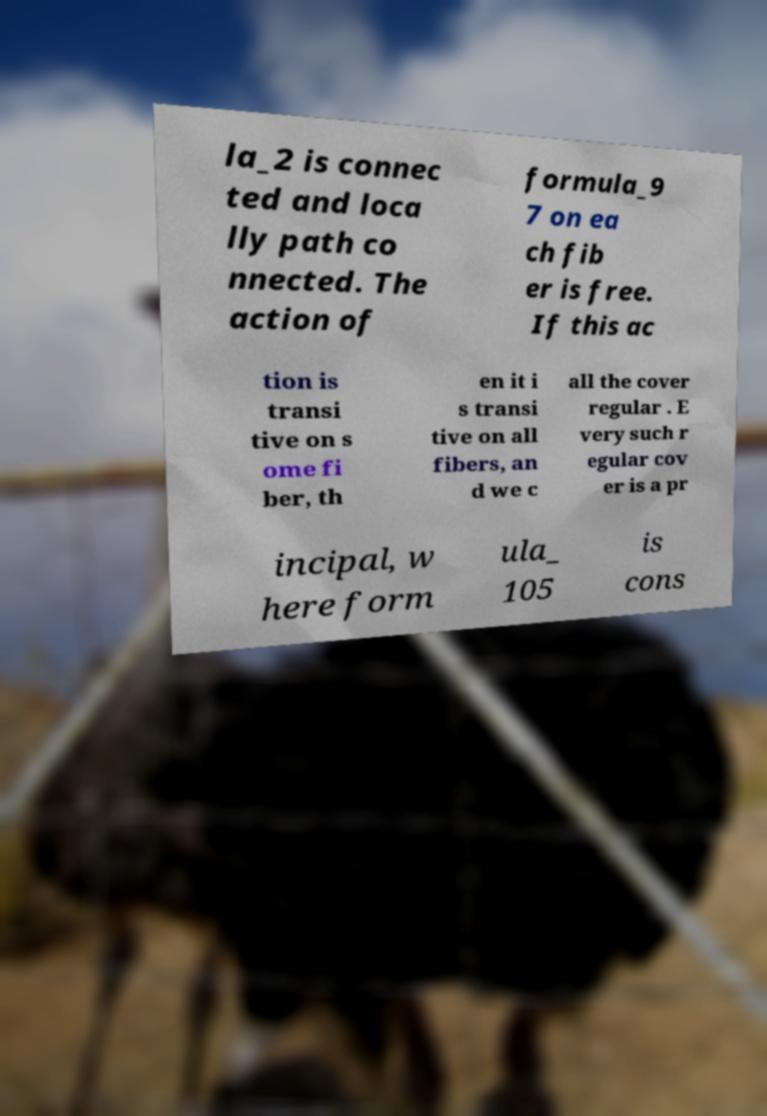Can you read and provide the text displayed in the image?This photo seems to have some interesting text. Can you extract and type it out for me? la_2 is connec ted and loca lly path co nnected. The action of formula_9 7 on ea ch fib er is free. If this ac tion is transi tive on s ome fi ber, th en it i s transi tive on all fibers, an d we c all the cover regular . E very such r egular cov er is a pr incipal, w here form ula_ 105 is cons 